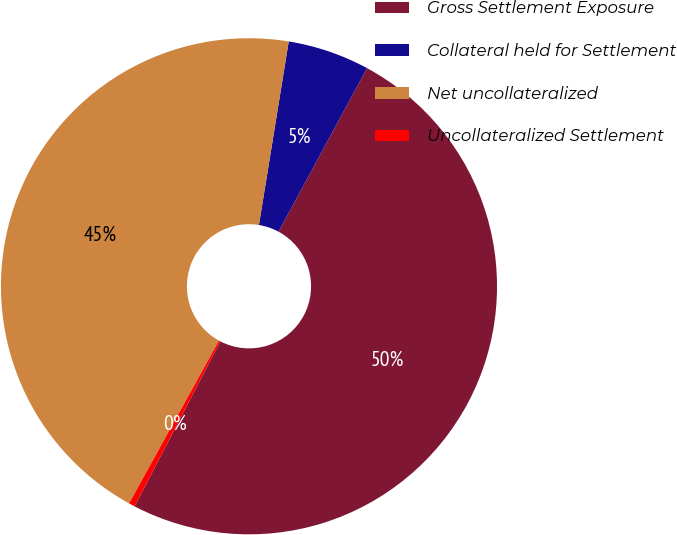<chart> <loc_0><loc_0><loc_500><loc_500><pie_chart><fcel>Gross Settlement Exposure<fcel>Collateral held for Settlement<fcel>Net uncollateralized<fcel>Uncollateralized Settlement<nl><fcel>49.74%<fcel>5.33%<fcel>44.53%<fcel>0.4%<nl></chart> 